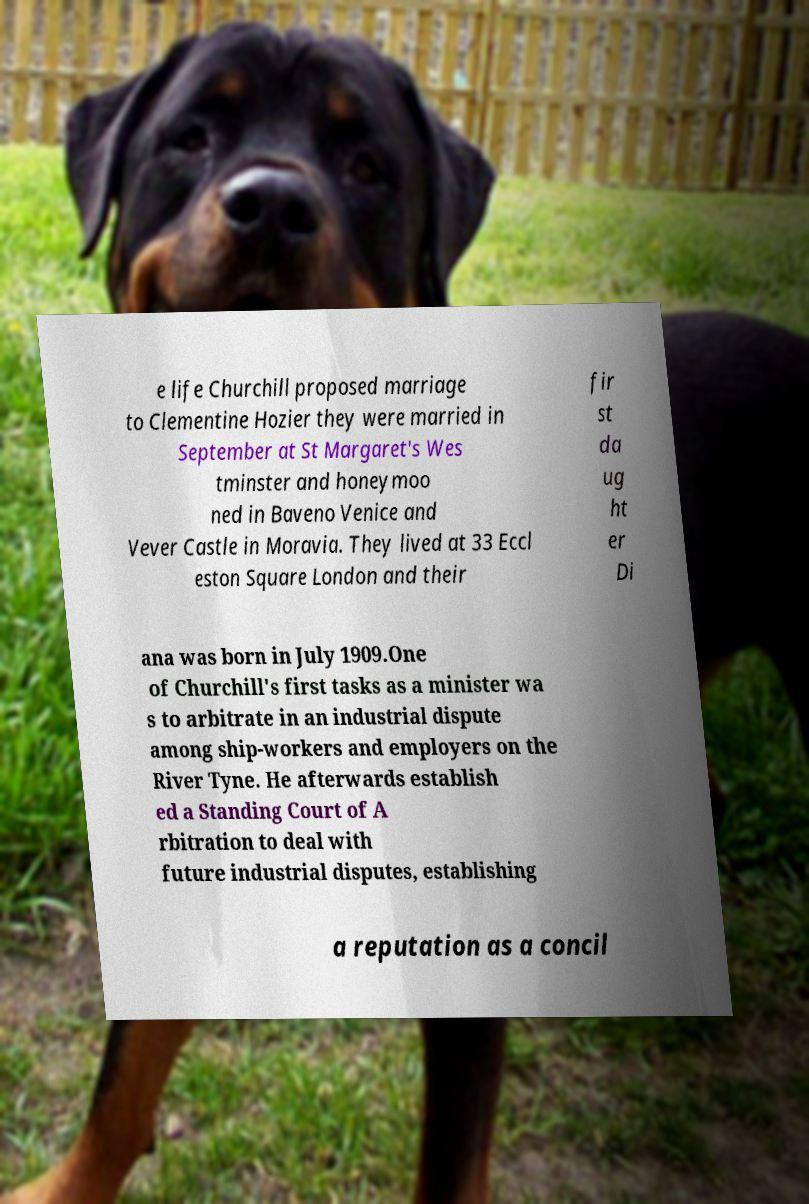Can you read and provide the text displayed in the image?This photo seems to have some interesting text. Can you extract and type it out for me? e life Churchill proposed marriage to Clementine Hozier they were married in September at St Margaret's Wes tminster and honeymoo ned in Baveno Venice and Vever Castle in Moravia. They lived at 33 Eccl eston Square London and their fir st da ug ht er Di ana was born in July 1909.One of Churchill's first tasks as a minister wa s to arbitrate in an industrial dispute among ship-workers and employers on the River Tyne. He afterwards establish ed a Standing Court of A rbitration to deal with future industrial disputes, establishing a reputation as a concil 